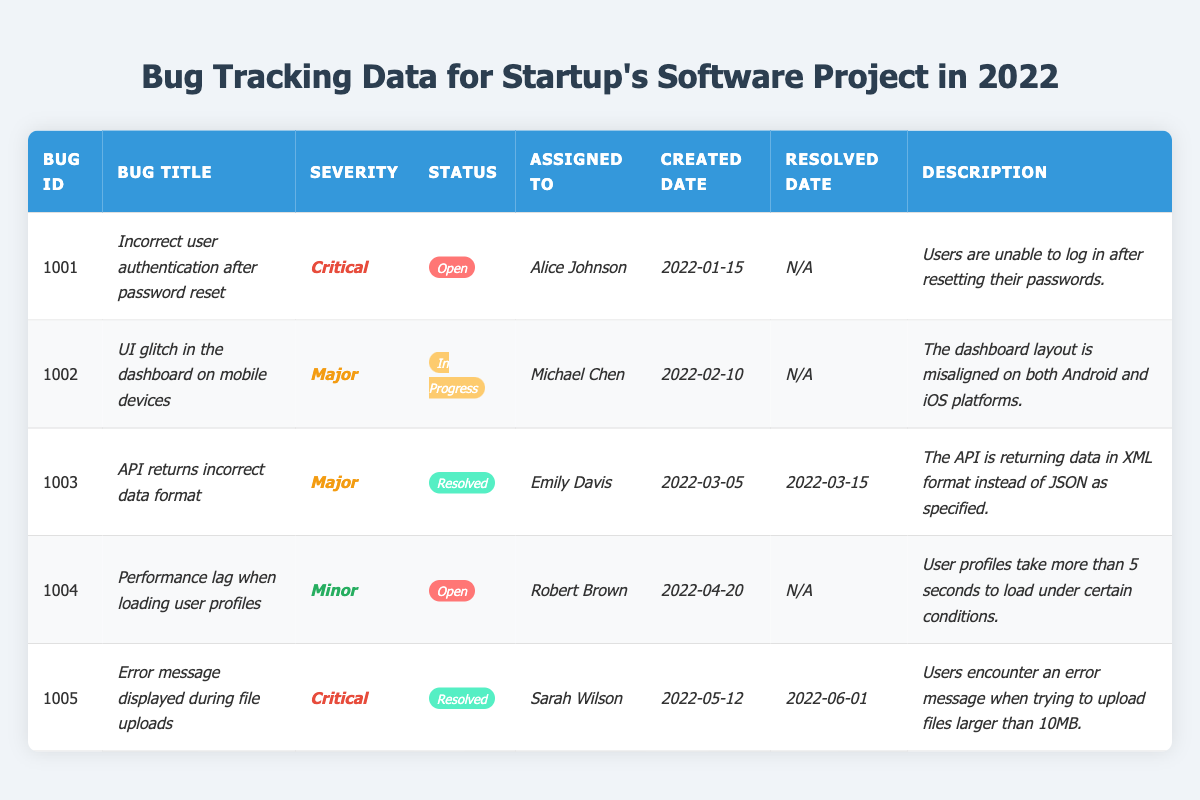What is the total number of bugs in the table? There are five entries in the table, each representing a different bug. Therefore, the total number of bugs is simply the count of these entries.
Answer: 5 Which bug has the highest severity level? The bugs with the highest severity level are classified as *Critical*. There are two bugs with this severity level: *Incorrect user authentication after password reset* and *Error message displayed during file uploads*.
Answer: *Incorrect user authentication after password reset* and *Error message displayed during file uploads* What is the status of bug ID 1004? Looking at bug ID 1004, its status is clearly labeled as *Open* in the status column.
Answer: *Open* How many bugs are currently resolved? By examining the statuses, there are two bugs with the status of *Resolved* (bug ID 1003 and 1005). Therefore, we count these entries to find the total.
Answer: 2 Is there any bug assigned to Alice Johnson? Yes, bug ID 1001 is assigned to Alice Johnson, as seen in the assignedTo column.
Answer: Yes What is the severity of the bug titled *UI glitch in the dashboard on mobile devices*? By checking the corresponding row for this bug, we see that the severity level associated with this bug is *Major*.
Answer: *Major* How many bugs were created in January 2022? Examining the created dates, only bug ID 1001 was created in January 2022. Thus, there is only one entry for that month.
Answer: 1 Which bug was resolved first based on the resolved date? Among the resolved bugs, bug ID 1003 was resolved on *2022-03-15*, and bug ID 1005 was resolved later on *2022-06-01*. Hence, bug ID 1003 was resolved first.
Answer: Bug ID 1003 What percentage of the bugs are still open? Out of 5 bugs, 3 bugs are open. To find the percentage: (3 open bugs / 5 total bugs) * 100 = 60%.
Answer: 60% Which assignee has worked on the most bugs? Both Alice Johnson and Sarah Wilson have one bug assigned to them while Michael Chen and Emily Davis also have one each. Robert Brown has one too, making it equal across all assignees.
Answer: All assignees have worked on 1 bug each 